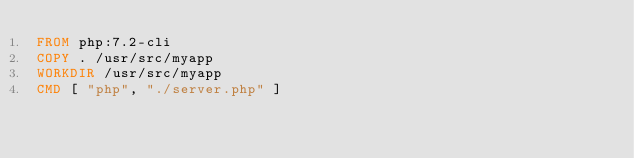<code> <loc_0><loc_0><loc_500><loc_500><_Dockerfile_>FROM php:7.2-cli
COPY . /usr/src/myapp
WORKDIR /usr/src/myapp
CMD [ "php", "./server.php" ]</code> 